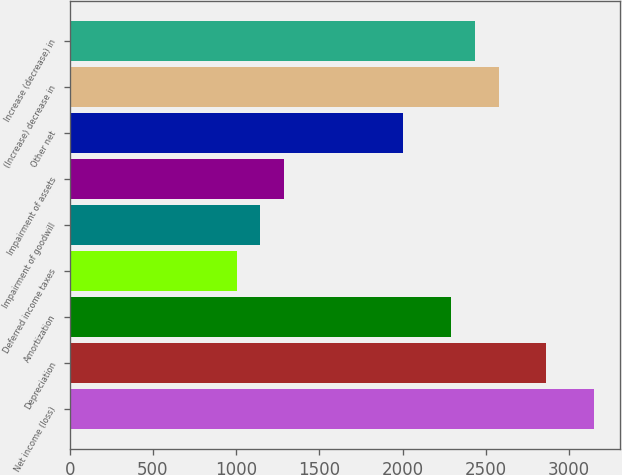Convert chart to OTSL. <chart><loc_0><loc_0><loc_500><loc_500><bar_chart><fcel>Net income (loss)<fcel>Depreciation<fcel>Amortization<fcel>Deferred income taxes<fcel>Impairment of goodwill<fcel>Impairment of assets<fcel>Other net<fcel>(Increase) decrease in<fcel>Increase (decrease) in<nl><fcel>3149.85<fcel>2863.53<fcel>2290.89<fcel>1002.51<fcel>1145.66<fcel>1288.82<fcel>2004.58<fcel>2577.21<fcel>2434.05<nl></chart> 